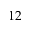Convert formula to latex. <formula><loc_0><loc_0><loc_500><loc_500>1 2</formula> 